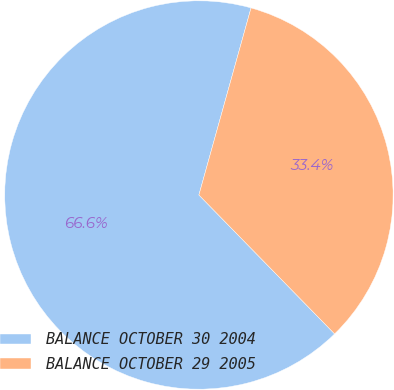Convert chart. <chart><loc_0><loc_0><loc_500><loc_500><pie_chart><fcel>BALANCE OCTOBER 30 2004<fcel>BALANCE OCTOBER 29 2005<nl><fcel>66.64%<fcel>33.36%<nl></chart> 